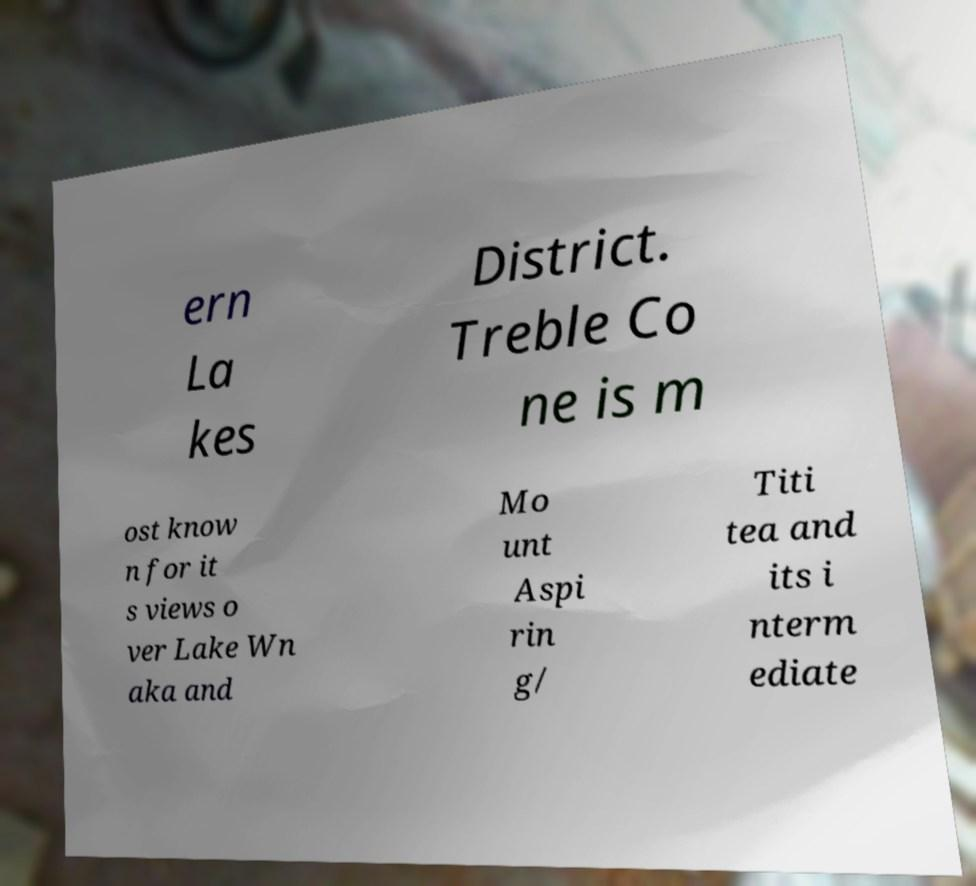Can you read and provide the text displayed in the image?This photo seems to have some interesting text. Can you extract and type it out for me? ern La kes District. Treble Co ne is m ost know n for it s views o ver Lake Wn aka and Mo unt Aspi rin g/ Titi tea and its i nterm ediate 